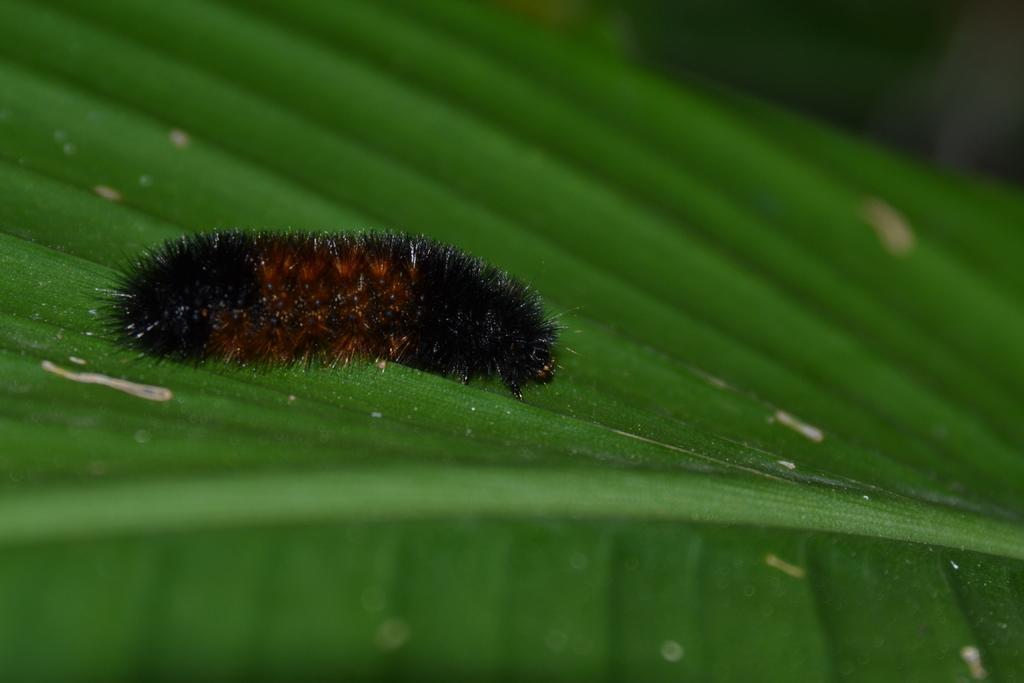In one or two sentences, can you explain what this image depicts? In this image I can see a black color caterpillar on a green color leaf. 